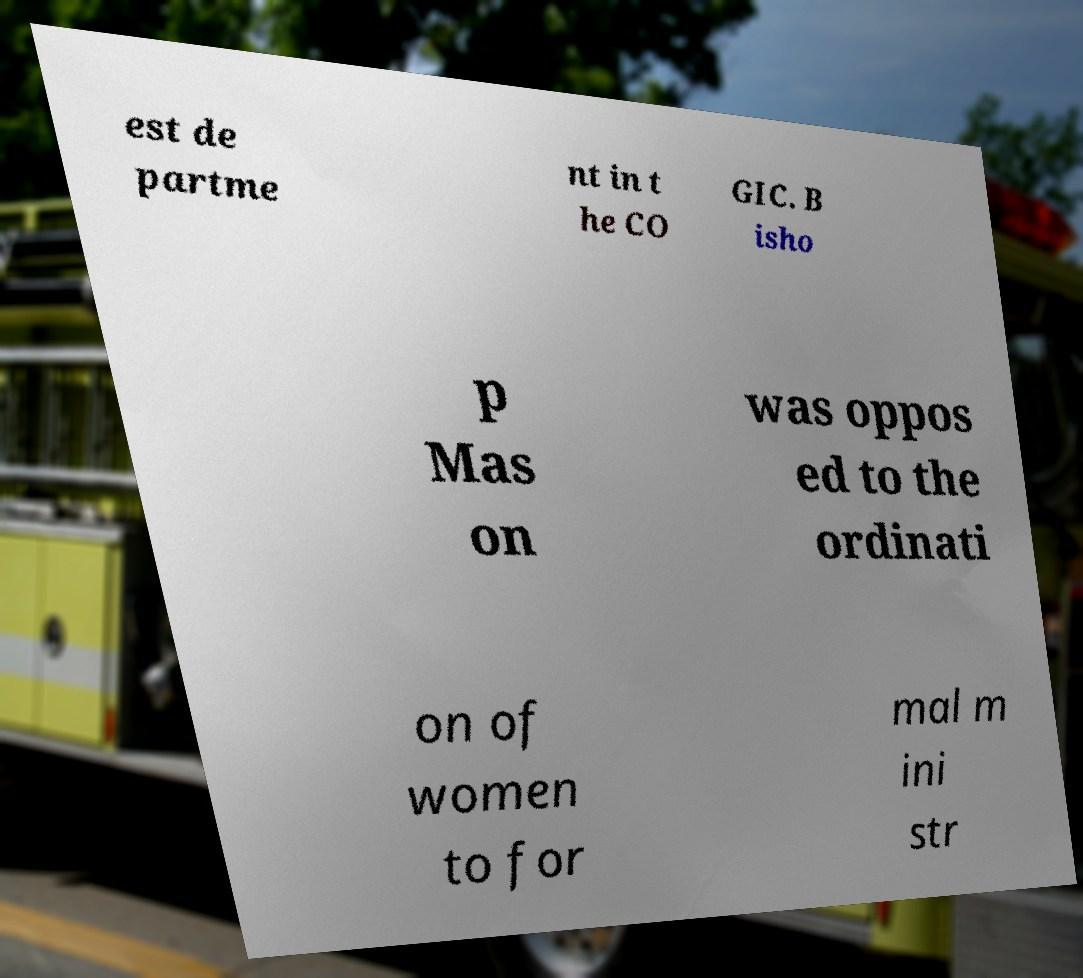What messages or text are displayed in this image? I need them in a readable, typed format. est de partme nt in t he CO GIC. B isho p Mas on was oppos ed to the ordinati on of women to for mal m ini str 